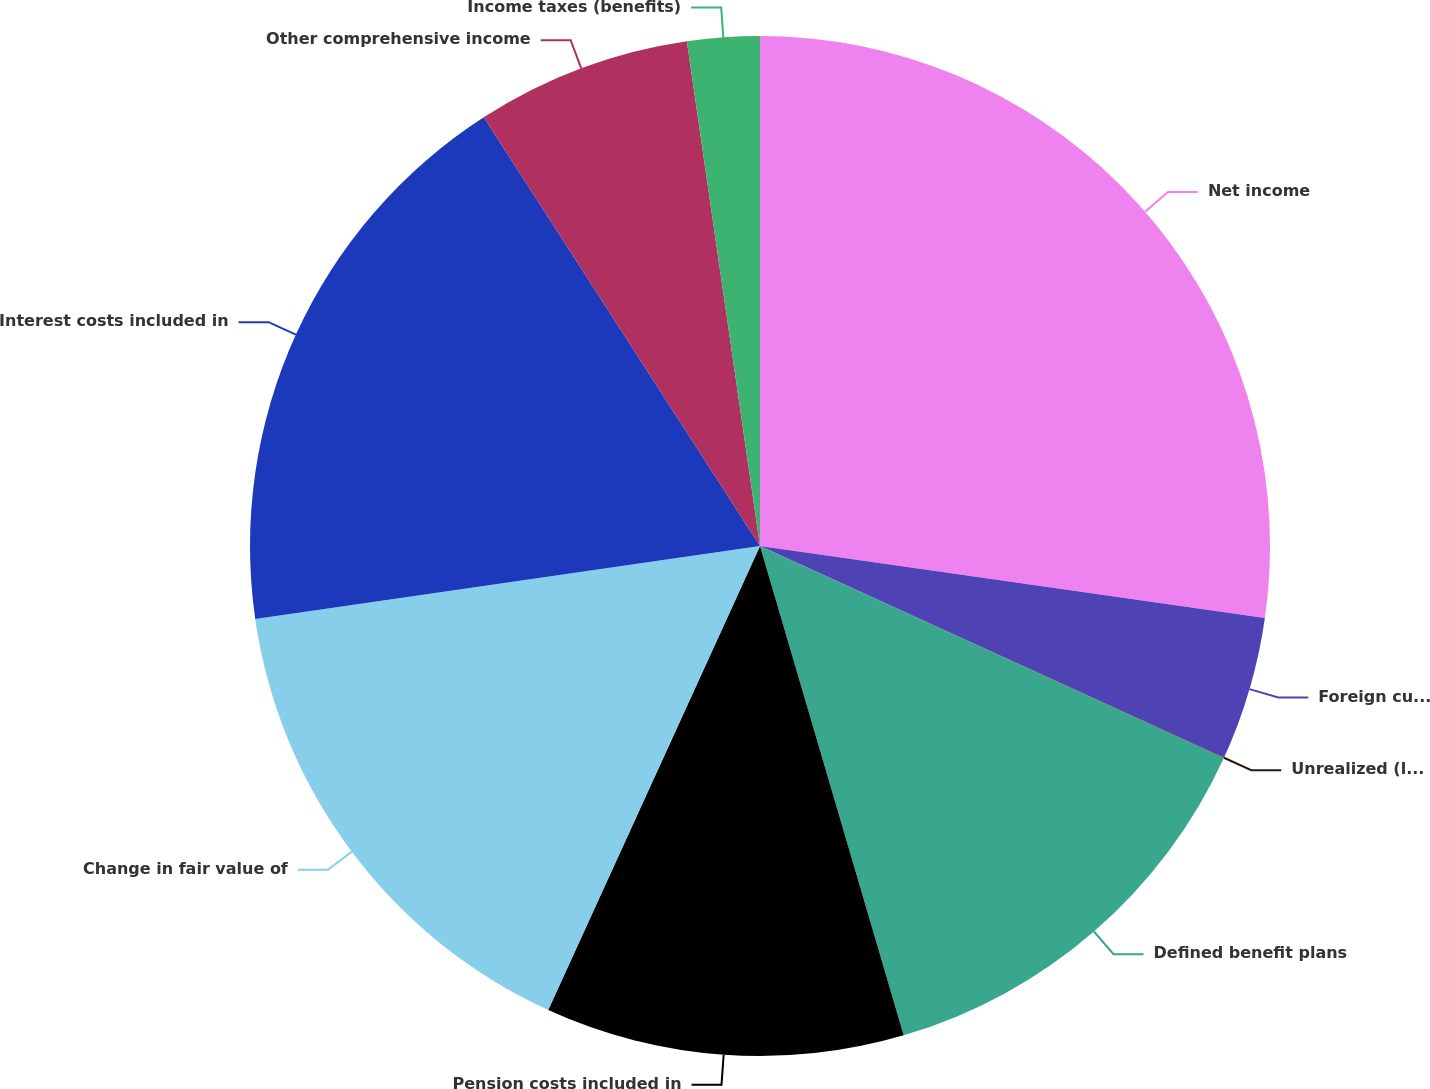Convert chart. <chart><loc_0><loc_0><loc_500><loc_500><pie_chart><fcel>Net income<fcel>Foreign currency translation<fcel>Unrealized (losses) gains on<fcel>Defined benefit plans<fcel>Pension costs included in<fcel>Change in fair value of<fcel>Interest costs included in<fcel>Other comprehensive income<fcel>Income taxes (benefits)<nl><fcel>27.25%<fcel>4.55%<fcel>0.02%<fcel>13.63%<fcel>11.36%<fcel>15.9%<fcel>18.17%<fcel>6.82%<fcel>2.29%<nl></chart> 